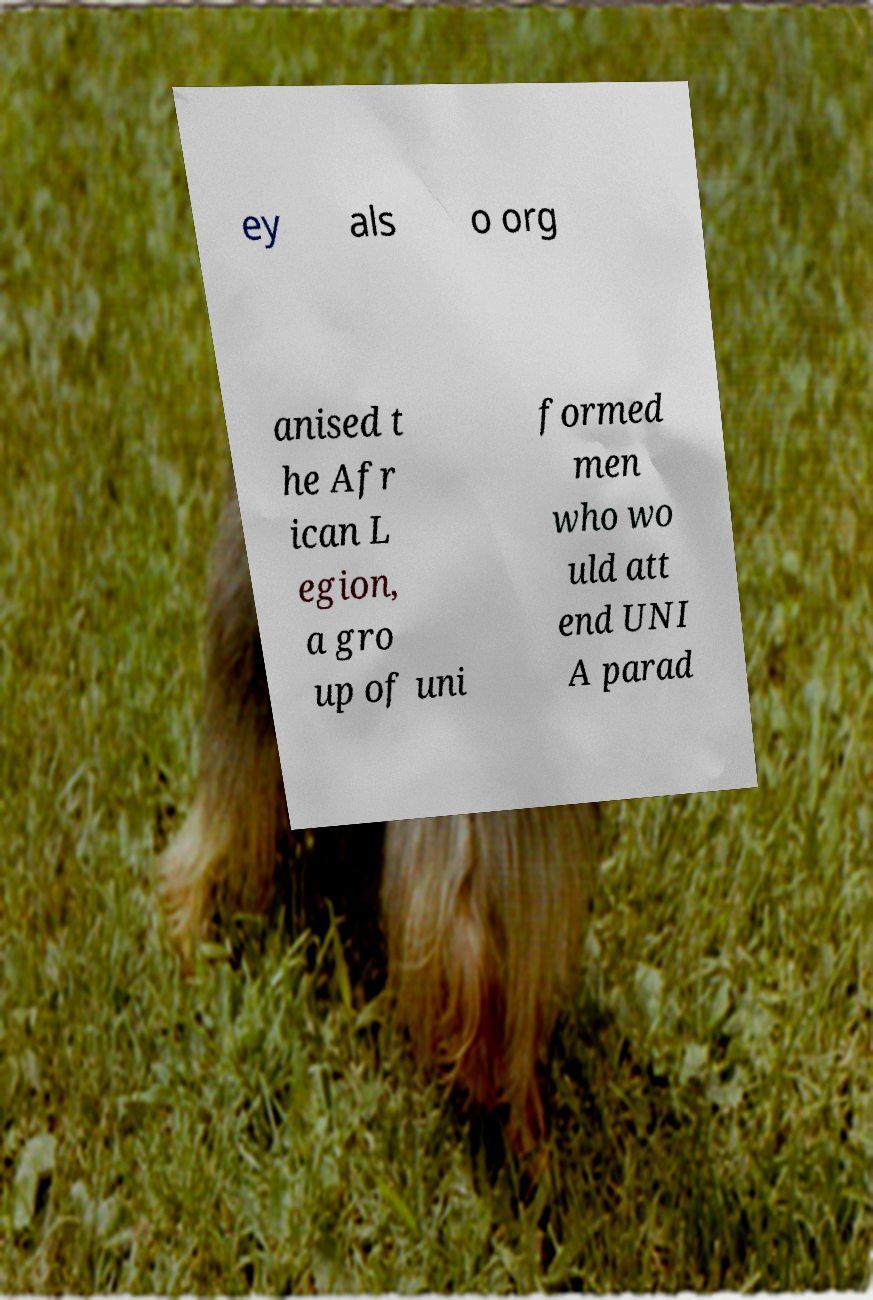I need the written content from this picture converted into text. Can you do that? ey als o org anised t he Afr ican L egion, a gro up of uni formed men who wo uld att end UNI A parad 